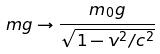Convert formula to latex. <formula><loc_0><loc_0><loc_500><loc_500>m g \rightarrow \frac { m _ { 0 } g } { \sqrt { 1 - v ^ { 2 } / c ^ { 2 } } }</formula> 